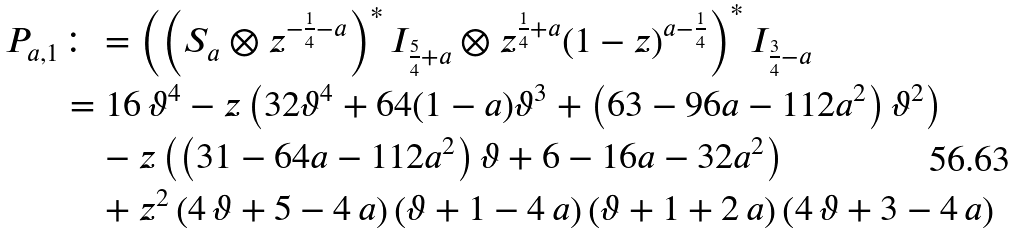Convert formula to latex. <formula><loc_0><loc_0><loc_500><loc_500>P _ { a , 1 } & \colon = \left ( \left ( S _ { a } \otimes z ^ { - \frac { 1 } { 4 } - a } \right ) ^ { * } I _ { \frac { 5 } { 4 } + a } \otimes z ^ { \frac { 1 } { 4 } + a } ( 1 - z ) ^ { a - \frac { 1 } { 4 } } \right ) ^ { * } I _ { \frac { 3 } { 4 } - a } \\ & = 1 6 \, { \vartheta } ^ { 4 } - z \left ( 3 2 \vartheta ^ { 4 } + 6 4 ( 1 - a ) \vartheta ^ { 3 } + \left ( 6 3 - 9 6 a - 1 1 2 a ^ { 2 } \right ) \vartheta ^ { 2 } \right ) \\ & \quad - z \left ( \left ( 3 1 - 6 4 a - 1 1 2 a ^ { 2 } \right ) \vartheta + 6 - 1 6 a - 3 2 a ^ { 2 } \right ) \\ & \quad + { z } ^ { 2 } \left ( 4 \, \vartheta + 5 - 4 \, a \right ) \left ( \vartheta + 1 - 4 \, a \right ) \left ( \vartheta + 1 + 2 \, a \right ) \left ( 4 \, \vartheta + 3 - 4 \, a \right )</formula> 